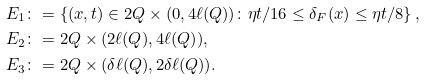Convert formula to latex. <formula><loc_0><loc_0><loc_500><loc_500>E _ { 1 } & \colon = \left \{ ( x , t ) \in 2 Q \times ( 0 , 4 \ell ( Q ) ) \colon { \eta t } / { 1 6 } \leq \delta _ { F } ( x ) \leq { \eta t } / { 8 } \right \} , \\ E _ { 2 } & \colon = 2 Q \times ( 2 \ell ( Q ) , 4 \ell ( Q ) ) , \\ E _ { 3 } & \colon = 2 Q \times ( \delta \ell ( Q ) , 2 \delta \ell ( Q ) ) .</formula> 